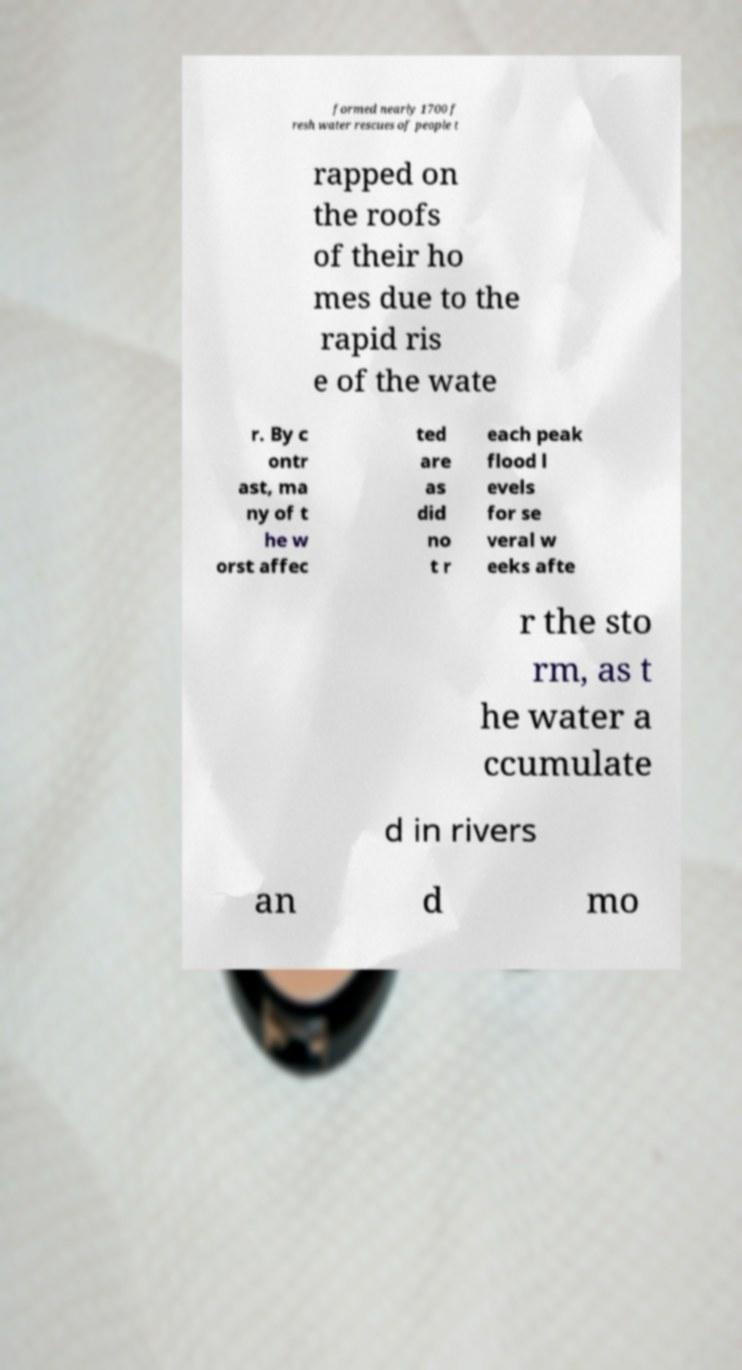For documentation purposes, I need the text within this image transcribed. Could you provide that? formed nearly 1700 f resh water rescues of people t rapped on the roofs of their ho mes due to the rapid ris e of the wate r. By c ontr ast, ma ny of t he w orst affec ted are as did no t r each peak flood l evels for se veral w eeks afte r the sto rm, as t he water a ccumulate d in rivers an d mo 